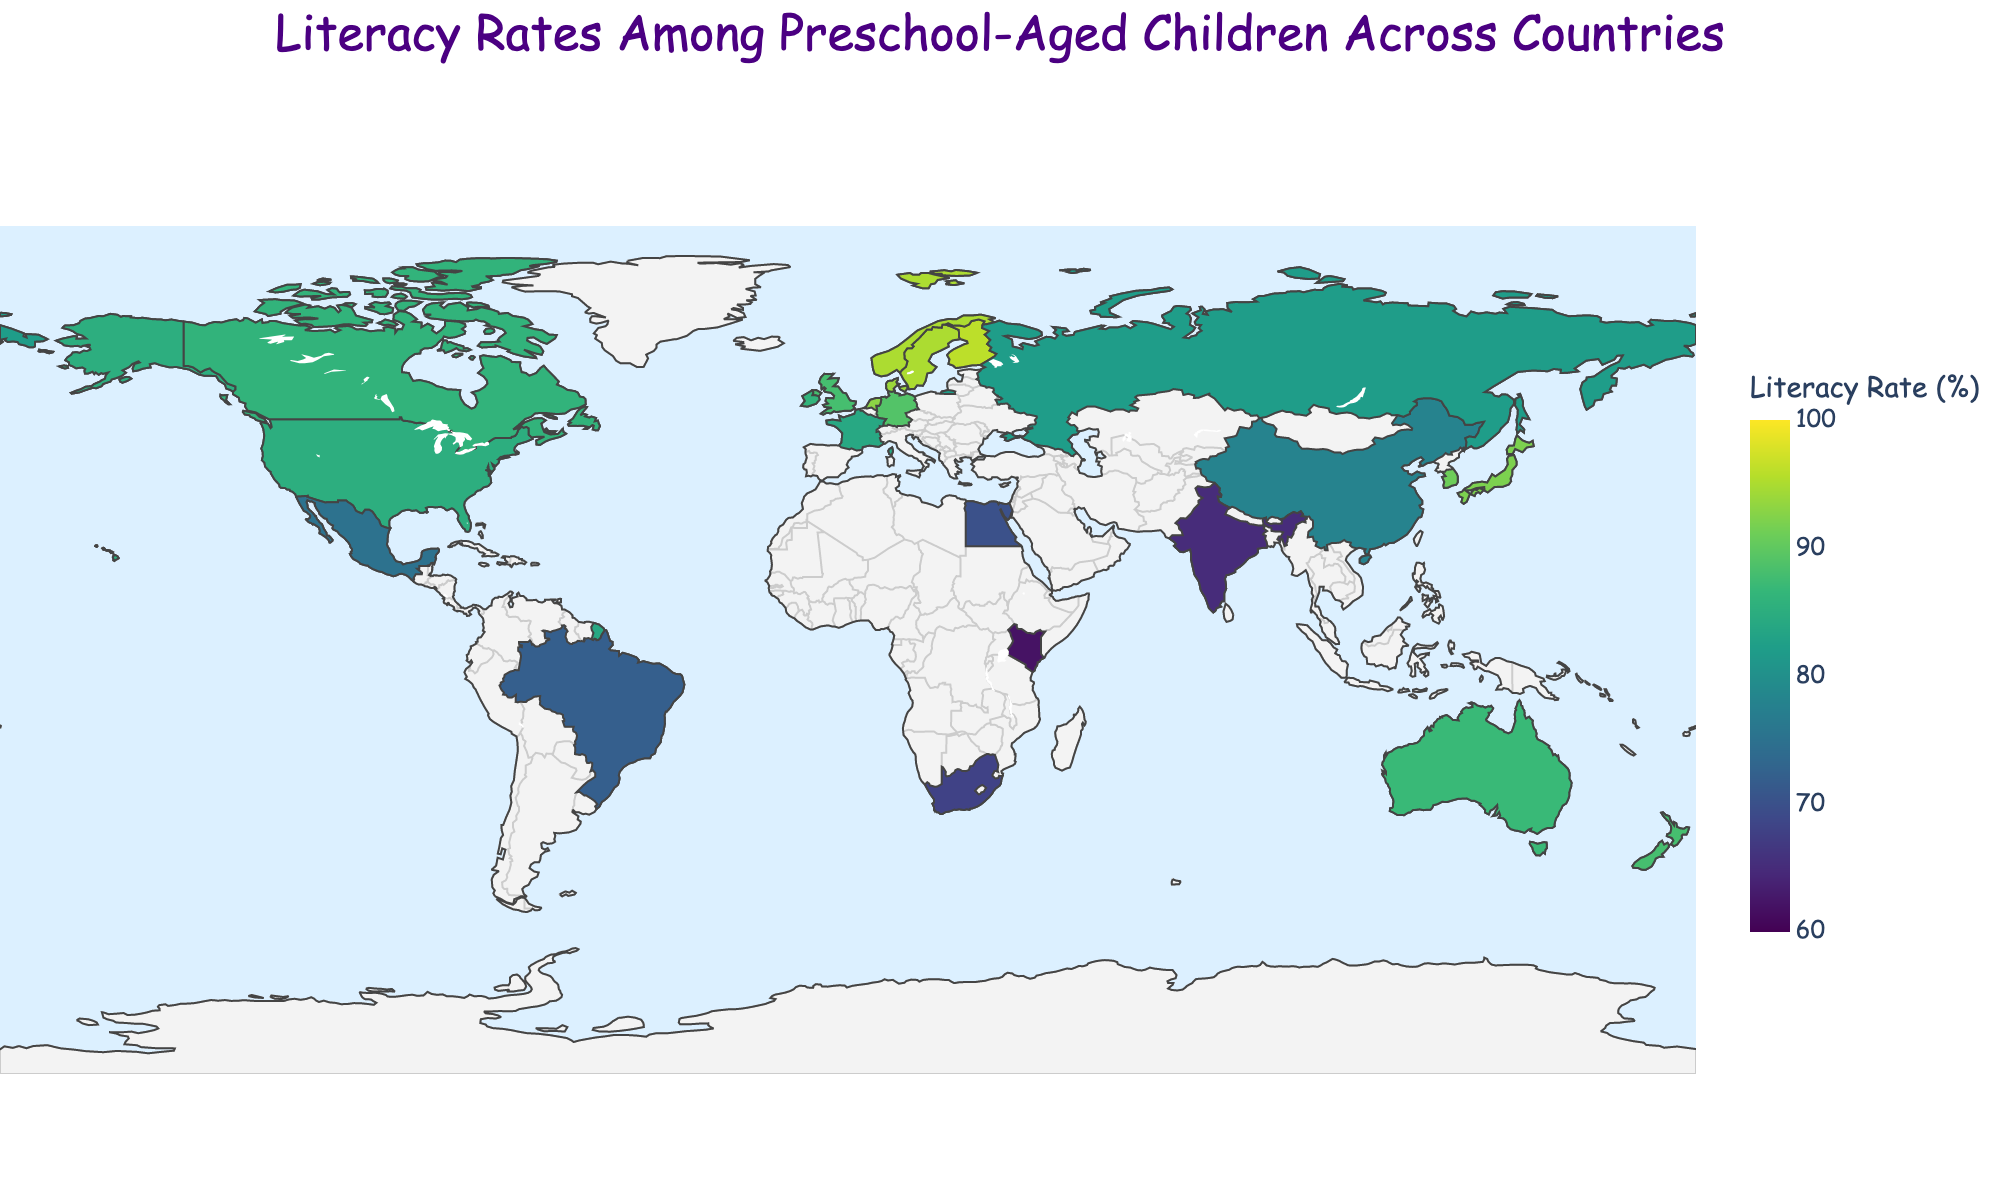What is the title of the figure? The title of the figure can be found at the top of the chart, which describes what the plot is visualizing.
Answer: Literacy Rates Among Preschool-Aged Children Across Countries Which country has the highest literacy rate? To find the country with the highest literacy rate, look for the darkest shade (representing higher literacy rates) on the plot and hover over it to see the country's name.
Answer: Finland Which country has the lowest literacy rate? To locate the country with the lowest literacy rate, look for the lightest shade (representing lower literacy rates) on the plot and hover over it to see the country's name.
Answer: Kenya What is the average literacy rate across all countries? First, sum up the literacy rates of all countries, then divide by the number of countries (24). The total is 1890, so the average is 1890/24.
Answer: 78.75 How does the literacy rate in the United States compare to that in the United Kingdom? Find the individual rates for the United States (85%) and the United Kingdom (88%) on the plot and compare them.
Answer: The United Kingdom's rate is higher Which countries have a literacy rate above 90%? Identify countries colored in the darkest shades and hover over them to find those with literacy rates above 90%.
Answer: Japan, Sweden, Finland, South Korea, Netherlands, Denmark, Norway By how much does India's literacy rate differ from China's? Find India's literacy rate (65%) and China's literacy rate (78%) on the plot, then calculate the difference, which is 78 - 65.
Answer: 13 How many countries have a literacy rate below 70%? Count the countries on the plot with a literacy rate below 70%, indicated by the lighter shades.
Answer: 4 Which country among France, Germany, and Italy has the lowest literacy rate? Hover over France (84%), Germany (89%), and Italy (not listed) on the plot to compare their literacy rates.
Answer: France What is the range of literacy rates shown in the plot? Identify the highest (Finland, 96%) and the lowest (Kenya, 62%) literacy rates on the plot and calculate the range, which is 96 - 62.
Answer: 34 